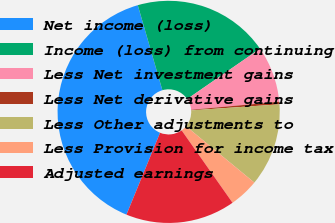<chart> <loc_0><loc_0><loc_500><loc_500><pie_chart><fcel>Net income (loss)<fcel>Income (loss) from continuing<fcel>Less Net investment gains<fcel>Less Net derivative gains<fcel>Less Other adjustments to<fcel>Less Provision for income tax<fcel>Adjusted earnings<nl><fcel>39.32%<fcel>19.85%<fcel>8.17%<fcel>0.38%<fcel>12.06%<fcel>4.27%<fcel>15.95%<nl></chart> 